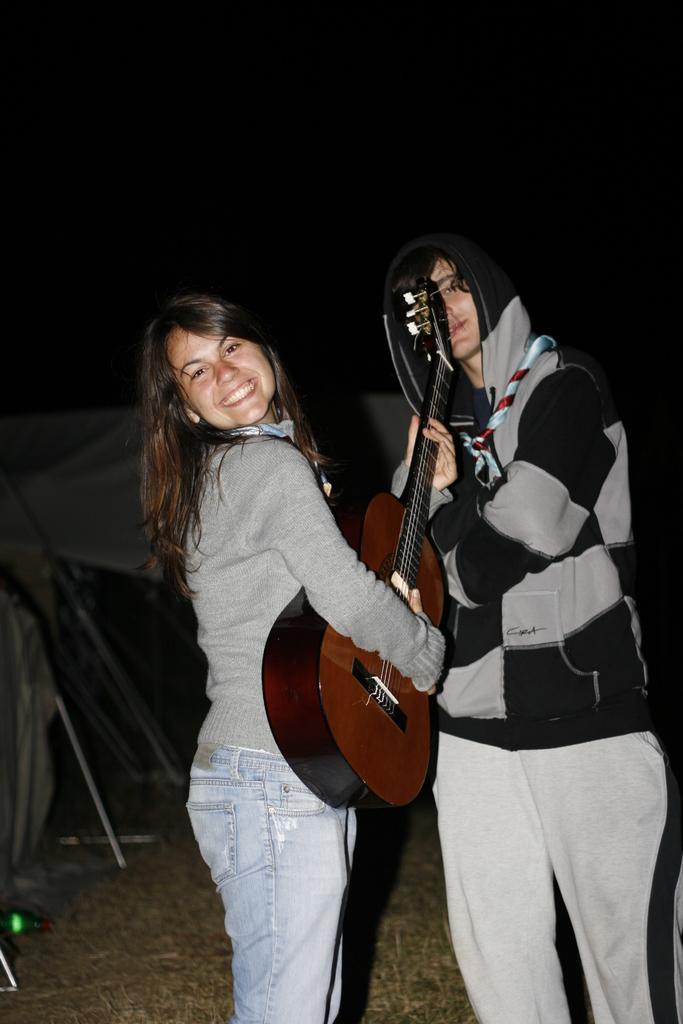Could you give a brief overview of what you see in this image? In this image there is a woman standing and smiling by holding a guitar , there is another man standing and holding a guitar in her hand. 